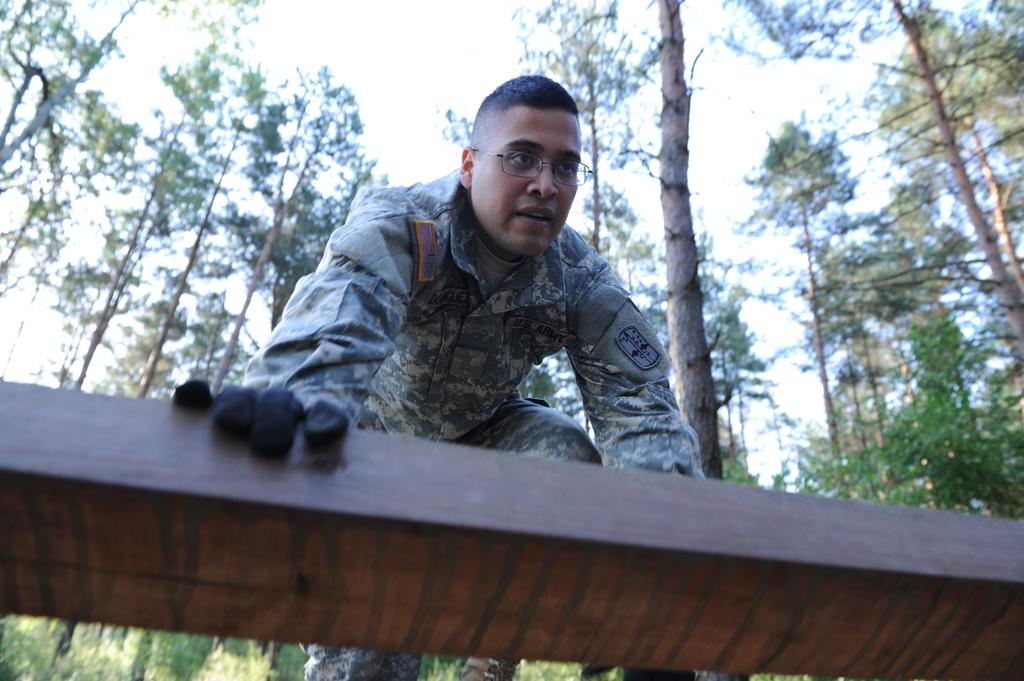What is the main subject of the image? There is a person standing in the center of the image. What is the person holding in the image? The person is holding wood. What can be seen in the background of the image? There is sky, clouds, and trees visible in the background of the image. What decision is the woman making in the image? There is no woman present in the image, and no decision-making process is depicted. 